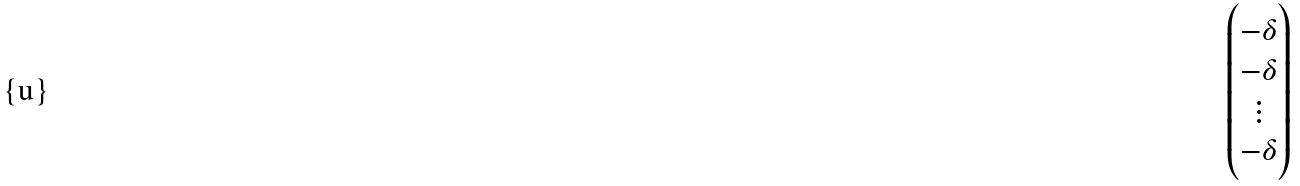<formula> <loc_0><loc_0><loc_500><loc_500>\begin{pmatrix} - \delta \\ - \delta \\ \vdots \\ - \delta \end{pmatrix}</formula> 